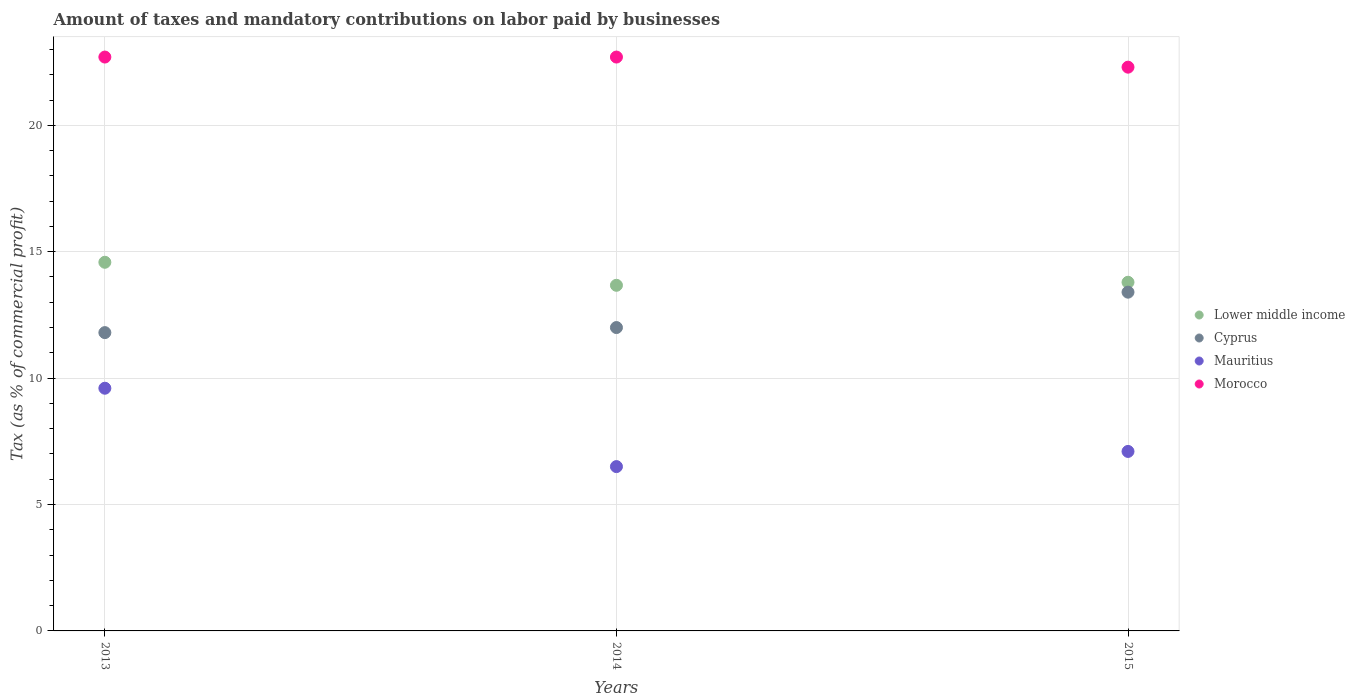Is the number of dotlines equal to the number of legend labels?
Provide a short and direct response. Yes. What is the percentage of taxes paid by businesses in Morocco in 2013?
Your answer should be compact. 22.7. Across all years, what is the minimum percentage of taxes paid by businesses in Cyprus?
Ensure brevity in your answer.  11.8. In which year was the percentage of taxes paid by businesses in Morocco maximum?
Your response must be concise. 2013. What is the total percentage of taxes paid by businesses in Lower middle income in the graph?
Offer a very short reply. 42.05. What is the difference between the percentage of taxes paid by businesses in Mauritius in 2013 and that in 2014?
Keep it short and to the point. 3.1. What is the difference between the percentage of taxes paid by businesses in Lower middle income in 2015 and the percentage of taxes paid by businesses in Mauritius in 2013?
Keep it short and to the point. 4.19. What is the average percentage of taxes paid by businesses in Lower middle income per year?
Give a very brief answer. 14.02. In the year 2015, what is the difference between the percentage of taxes paid by businesses in Lower middle income and percentage of taxes paid by businesses in Mauritius?
Offer a very short reply. 6.69. In how many years, is the percentage of taxes paid by businesses in Morocco greater than 2 %?
Your answer should be compact. 3. What is the ratio of the percentage of taxes paid by businesses in Morocco in 2014 to that in 2015?
Offer a terse response. 1.02. Is the percentage of taxes paid by businesses in Morocco in 2013 less than that in 2015?
Provide a succinct answer. No. Is the difference between the percentage of taxes paid by businesses in Lower middle income in 2013 and 2015 greater than the difference between the percentage of taxes paid by businesses in Mauritius in 2013 and 2015?
Offer a very short reply. No. What is the difference between the highest and the second highest percentage of taxes paid by businesses in Lower middle income?
Provide a short and direct response. 0.79. What is the difference between the highest and the lowest percentage of taxes paid by businesses in Cyprus?
Provide a succinct answer. 1.6. Is it the case that in every year, the sum of the percentage of taxes paid by businesses in Lower middle income and percentage of taxes paid by businesses in Mauritius  is greater than the percentage of taxes paid by businesses in Cyprus?
Offer a terse response. Yes. Does the percentage of taxes paid by businesses in Mauritius monotonically increase over the years?
Give a very brief answer. No. Is the percentage of taxes paid by businesses in Lower middle income strictly less than the percentage of taxes paid by businesses in Cyprus over the years?
Your answer should be very brief. No. Does the graph contain any zero values?
Your answer should be compact. No. Does the graph contain grids?
Offer a terse response. Yes. Where does the legend appear in the graph?
Provide a succinct answer. Center right. How are the legend labels stacked?
Provide a succinct answer. Vertical. What is the title of the graph?
Provide a short and direct response. Amount of taxes and mandatory contributions on labor paid by businesses. Does "Lesotho" appear as one of the legend labels in the graph?
Your answer should be very brief. No. What is the label or title of the Y-axis?
Offer a very short reply. Tax (as % of commercial profit). What is the Tax (as % of commercial profit) in Lower middle income in 2013?
Your answer should be compact. 14.58. What is the Tax (as % of commercial profit) of Cyprus in 2013?
Offer a very short reply. 11.8. What is the Tax (as % of commercial profit) of Mauritius in 2013?
Your response must be concise. 9.6. What is the Tax (as % of commercial profit) of Morocco in 2013?
Offer a very short reply. 22.7. What is the Tax (as % of commercial profit) of Lower middle income in 2014?
Provide a short and direct response. 13.67. What is the Tax (as % of commercial profit) of Morocco in 2014?
Provide a succinct answer. 22.7. What is the Tax (as % of commercial profit) of Lower middle income in 2015?
Your answer should be compact. 13.79. What is the Tax (as % of commercial profit) of Cyprus in 2015?
Your answer should be compact. 13.4. What is the Tax (as % of commercial profit) of Mauritius in 2015?
Keep it short and to the point. 7.1. What is the Tax (as % of commercial profit) of Morocco in 2015?
Give a very brief answer. 22.3. Across all years, what is the maximum Tax (as % of commercial profit) of Lower middle income?
Keep it short and to the point. 14.58. Across all years, what is the maximum Tax (as % of commercial profit) in Mauritius?
Provide a succinct answer. 9.6. Across all years, what is the maximum Tax (as % of commercial profit) in Morocco?
Offer a terse response. 22.7. Across all years, what is the minimum Tax (as % of commercial profit) of Lower middle income?
Your answer should be compact. 13.67. Across all years, what is the minimum Tax (as % of commercial profit) of Mauritius?
Your answer should be very brief. 6.5. Across all years, what is the minimum Tax (as % of commercial profit) in Morocco?
Give a very brief answer. 22.3. What is the total Tax (as % of commercial profit) in Lower middle income in the graph?
Provide a succinct answer. 42.05. What is the total Tax (as % of commercial profit) in Cyprus in the graph?
Ensure brevity in your answer.  37.2. What is the total Tax (as % of commercial profit) in Mauritius in the graph?
Offer a terse response. 23.2. What is the total Tax (as % of commercial profit) in Morocco in the graph?
Offer a terse response. 67.7. What is the difference between the Tax (as % of commercial profit) of Lower middle income in 2013 and that in 2014?
Keep it short and to the point. 0.91. What is the difference between the Tax (as % of commercial profit) in Cyprus in 2013 and that in 2014?
Your response must be concise. -0.2. What is the difference between the Tax (as % of commercial profit) in Mauritius in 2013 and that in 2014?
Offer a terse response. 3.1. What is the difference between the Tax (as % of commercial profit) in Lower middle income in 2013 and that in 2015?
Give a very brief answer. 0.79. What is the difference between the Tax (as % of commercial profit) in Cyprus in 2013 and that in 2015?
Provide a succinct answer. -1.6. What is the difference between the Tax (as % of commercial profit) in Mauritius in 2013 and that in 2015?
Make the answer very short. 2.5. What is the difference between the Tax (as % of commercial profit) in Morocco in 2013 and that in 2015?
Keep it short and to the point. 0.4. What is the difference between the Tax (as % of commercial profit) in Lower middle income in 2014 and that in 2015?
Give a very brief answer. -0.12. What is the difference between the Tax (as % of commercial profit) in Cyprus in 2014 and that in 2015?
Provide a succinct answer. -1.4. What is the difference between the Tax (as % of commercial profit) of Mauritius in 2014 and that in 2015?
Offer a very short reply. -0.6. What is the difference between the Tax (as % of commercial profit) of Lower middle income in 2013 and the Tax (as % of commercial profit) of Cyprus in 2014?
Make the answer very short. 2.58. What is the difference between the Tax (as % of commercial profit) in Lower middle income in 2013 and the Tax (as % of commercial profit) in Mauritius in 2014?
Your answer should be very brief. 8.08. What is the difference between the Tax (as % of commercial profit) of Lower middle income in 2013 and the Tax (as % of commercial profit) of Morocco in 2014?
Give a very brief answer. -8.12. What is the difference between the Tax (as % of commercial profit) of Lower middle income in 2013 and the Tax (as % of commercial profit) of Cyprus in 2015?
Provide a short and direct response. 1.18. What is the difference between the Tax (as % of commercial profit) in Lower middle income in 2013 and the Tax (as % of commercial profit) in Mauritius in 2015?
Your answer should be compact. 7.48. What is the difference between the Tax (as % of commercial profit) in Lower middle income in 2013 and the Tax (as % of commercial profit) in Morocco in 2015?
Provide a succinct answer. -7.72. What is the difference between the Tax (as % of commercial profit) in Cyprus in 2013 and the Tax (as % of commercial profit) in Mauritius in 2015?
Your answer should be very brief. 4.7. What is the difference between the Tax (as % of commercial profit) in Cyprus in 2013 and the Tax (as % of commercial profit) in Morocco in 2015?
Your answer should be very brief. -10.5. What is the difference between the Tax (as % of commercial profit) of Mauritius in 2013 and the Tax (as % of commercial profit) of Morocco in 2015?
Your answer should be very brief. -12.7. What is the difference between the Tax (as % of commercial profit) in Lower middle income in 2014 and the Tax (as % of commercial profit) in Cyprus in 2015?
Ensure brevity in your answer.  0.27. What is the difference between the Tax (as % of commercial profit) of Lower middle income in 2014 and the Tax (as % of commercial profit) of Mauritius in 2015?
Offer a very short reply. 6.57. What is the difference between the Tax (as % of commercial profit) of Lower middle income in 2014 and the Tax (as % of commercial profit) of Morocco in 2015?
Keep it short and to the point. -8.63. What is the difference between the Tax (as % of commercial profit) in Cyprus in 2014 and the Tax (as % of commercial profit) in Mauritius in 2015?
Your answer should be very brief. 4.9. What is the difference between the Tax (as % of commercial profit) in Mauritius in 2014 and the Tax (as % of commercial profit) in Morocco in 2015?
Provide a succinct answer. -15.8. What is the average Tax (as % of commercial profit) in Lower middle income per year?
Keep it short and to the point. 14.02. What is the average Tax (as % of commercial profit) of Cyprus per year?
Give a very brief answer. 12.4. What is the average Tax (as % of commercial profit) in Mauritius per year?
Your response must be concise. 7.73. What is the average Tax (as % of commercial profit) of Morocco per year?
Keep it short and to the point. 22.57. In the year 2013, what is the difference between the Tax (as % of commercial profit) in Lower middle income and Tax (as % of commercial profit) in Cyprus?
Your answer should be compact. 2.78. In the year 2013, what is the difference between the Tax (as % of commercial profit) of Lower middle income and Tax (as % of commercial profit) of Mauritius?
Keep it short and to the point. 4.98. In the year 2013, what is the difference between the Tax (as % of commercial profit) in Lower middle income and Tax (as % of commercial profit) in Morocco?
Your response must be concise. -8.12. In the year 2013, what is the difference between the Tax (as % of commercial profit) in Cyprus and Tax (as % of commercial profit) in Morocco?
Keep it short and to the point. -10.9. In the year 2014, what is the difference between the Tax (as % of commercial profit) in Lower middle income and Tax (as % of commercial profit) in Cyprus?
Offer a terse response. 1.67. In the year 2014, what is the difference between the Tax (as % of commercial profit) in Lower middle income and Tax (as % of commercial profit) in Mauritius?
Give a very brief answer. 7.17. In the year 2014, what is the difference between the Tax (as % of commercial profit) in Lower middle income and Tax (as % of commercial profit) in Morocco?
Provide a short and direct response. -9.03. In the year 2014, what is the difference between the Tax (as % of commercial profit) of Cyprus and Tax (as % of commercial profit) of Morocco?
Make the answer very short. -10.7. In the year 2014, what is the difference between the Tax (as % of commercial profit) in Mauritius and Tax (as % of commercial profit) in Morocco?
Your answer should be compact. -16.2. In the year 2015, what is the difference between the Tax (as % of commercial profit) of Lower middle income and Tax (as % of commercial profit) of Cyprus?
Your answer should be compact. 0.39. In the year 2015, what is the difference between the Tax (as % of commercial profit) in Lower middle income and Tax (as % of commercial profit) in Mauritius?
Keep it short and to the point. 6.69. In the year 2015, what is the difference between the Tax (as % of commercial profit) in Lower middle income and Tax (as % of commercial profit) in Morocco?
Your response must be concise. -8.51. In the year 2015, what is the difference between the Tax (as % of commercial profit) of Cyprus and Tax (as % of commercial profit) of Morocco?
Provide a short and direct response. -8.9. In the year 2015, what is the difference between the Tax (as % of commercial profit) of Mauritius and Tax (as % of commercial profit) of Morocco?
Give a very brief answer. -15.2. What is the ratio of the Tax (as % of commercial profit) in Lower middle income in 2013 to that in 2014?
Your answer should be compact. 1.07. What is the ratio of the Tax (as % of commercial profit) in Cyprus in 2013 to that in 2014?
Your response must be concise. 0.98. What is the ratio of the Tax (as % of commercial profit) of Mauritius in 2013 to that in 2014?
Offer a terse response. 1.48. What is the ratio of the Tax (as % of commercial profit) of Lower middle income in 2013 to that in 2015?
Offer a very short reply. 1.06. What is the ratio of the Tax (as % of commercial profit) of Cyprus in 2013 to that in 2015?
Your response must be concise. 0.88. What is the ratio of the Tax (as % of commercial profit) in Mauritius in 2013 to that in 2015?
Offer a very short reply. 1.35. What is the ratio of the Tax (as % of commercial profit) of Morocco in 2013 to that in 2015?
Keep it short and to the point. 1.02. What is the ratio of the Tax (as % of commercial profit) of Cyprus in 2014 to that in 2015?
Provide a short and direct response. 0.9. What is the ratio of the Tax (as % of commercial profit) in Mauritius in 2014 to that in 2015?
Offer a terse response. 0.92. What is the ratio of the Tax (as % of commercial profit) in Morocco in 2014 to that in 2015?
Give a very brief answer. 1.02. What is the difference between the highest and the second highest Tax (as % of commercial profit) of Lower middle income?
Provide a succinct answer. 0.79. What is the difference between the highest and the second highest Tax (as % of commercial profit) in Cyprus?
Offer a very short reply. 1.4. What is the difference between the highest and the second highest Tax (as % of commercial profit) in Morocco?
Your response must be concise. 0. What is the difference between the highest and the lowest Tax (as % of commercial profit) in Lower middle income?
Keep it short and to the point. 0.91. What is the difference between the highest and the lowest Tax (as % of commercial profit) of Cyprus?
Provide a succinct answer. 1.6. What is the difference between the highest and the lowest Tax (as % of commercial profit) in Mauritius?
Ensure brevity in your answer.  3.1. 